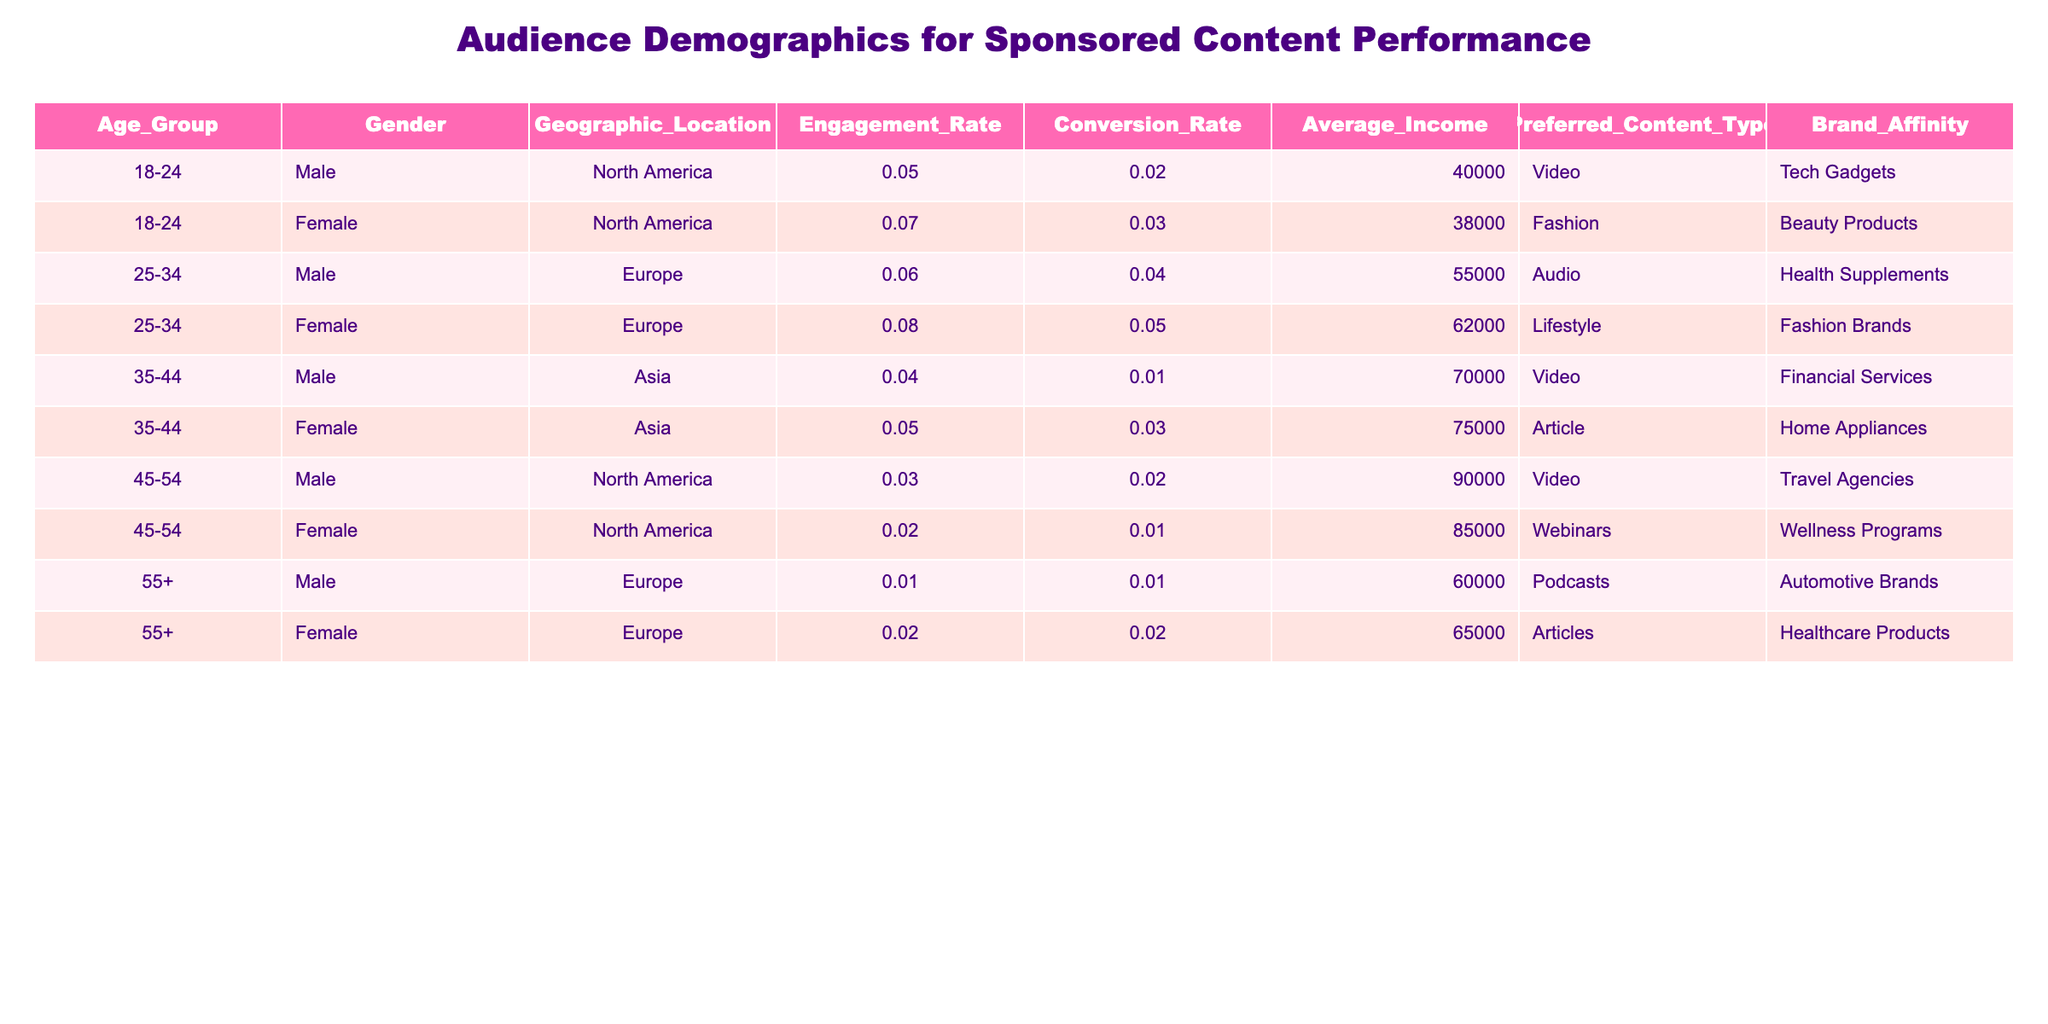What is the engagement rate for females in North America? From the table, we can find the row with "Female" and "North America," which shows an engagement rate of 0.07.
Answer: 0.07 What is the average income of the age group 35-44? There are two entries for the age group 35-44: Male (70000) and Female (75000). Adding these values gives 70000 + 75000 = 145000. There are two entries, so the average income is 145000 / 2 = 72500.
Answer: 72500 Are there any females aged 55+ with a preferred content type of "Podcasts"? The table shows that the 55+ Female has a preferred content type of "Articles," meaning there are no females aged 55+ with a preferred content type of "Podcasts."
Answer: No Which geographic location has the highest conversion rate for the 25-34 age group? In the 25-34 age group, we have two rows: Male in Europe with a conversion rate of 0.04 and Female in Europe with a conversion rate of 0.05. The highest conversion rate is 0.05 for Female in Europe.
Answer: 0.05 What is the difference in average income between males and females in the age group 45-54? For males in the 45-54 age group, the average income is 90000, and for females, it is 85000. The difference is 90000 - 85000 = 5000.
Answer: 5000 What content type is preferred by males aged 18-24 with the highest engagement rate? The entry for males aged 18-24 shows a preferred content type of "Video" and an engagement rate of 0.05. Since there are no other males aged 18-24 listed, this is the only entry for that group.
Answer: Video What percentage of females in North America have a conversion rate above 0.02? There are two females from North America: one aged 18-24 with a conversion rate of 0.03 and one aged 45-54 with a conversion rate of 0.01. Only the 18-24 female has a conversion rate above 0.02. Thus, the percentage is (1 / 2) * 100 = 50%.
Answer: 50% Is the average engagement rate for males in Asia higher than that for females in Asia? The engagement rate for males in Asia is 0.04, while for females it is 0.05. Since 0.04 is less than 0.05, the average engagement rate for males in Asia is not higher.
Answer: No 